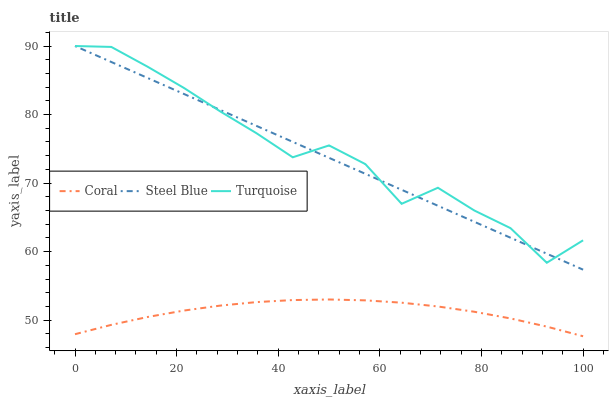Does Coral have the minimum area under the curve?
Answer yes or no. Yes. Does Turquoise have the maximum area under the curve?
Answer yes or no. Yes. Does Steel Blue have the minimum area under the curve?
Answer yes or no. No. Does Steel Blue have the maximum area under the curve?
Answer yes or no. No. Is Steel Blue the smoothest?
Answer yes or no. Yes. Is Turquoise the roughest?
Answer yes or no. Yes. Is Turquoise the smoothest?
Answer yes or no. No. Is Steel Blue the roughest?
Answer yes or no. No. Does Coral have the lowest value?
Answer yes or no. Yes. Does Steel Blue have the lowest value?
Answer yes or no. No. Does Steel Blue have the highest value?
Answer yes or no. Yes. Is Coral less than Turquoise?
Answer yes or no. Yes. Is Turquoise greater than Coral?
Answer yes or no. Yes. Does Steel Blue intersect Turquoise?
Answer yes or no. Yes. Is Steel Blue less than Turquoise?
Answer yes or no. No. Is Steel Blue greater than Turquoise?
Answer yes or no. No. Does Coral intersect Turquoise?
Answer yes or no. No. 